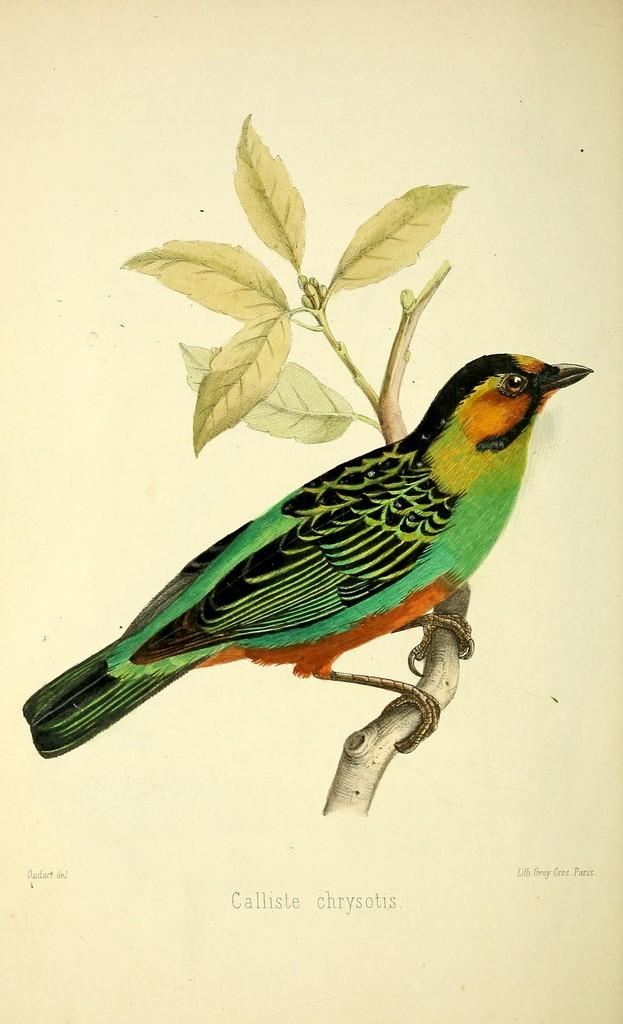What is depicted in the painting in the image? There is a painting of a bird in the image. How is the bird positioned in the painting? The bird is on a stem in the painting. What else can be seen on the stem besides the bird? There are leaves on the stem. What color is the background of the image? The background of the image is white. What is written at the bottom of the image? There is text at the bottom of the image. How many pests can be seen crawling on the bird in the image? There are no pests visible in the image; it features a painting of a bird on a stem with leaves. What type of footwear is the bird wearing in the image? The bird is a painted subject and does not have footwear. 